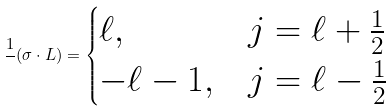<formula> <loc_0><loc_0><loc_500><loc_500>\frac { 1 } { } ( \sigma \cdot L ) = \begin{cases} \ell , & j = \ell + \frac { 1 } { 2 } \\ - \ell - 1 , & j = \ell - \frac { 1 } { 2 } \end{cases}</formula> 